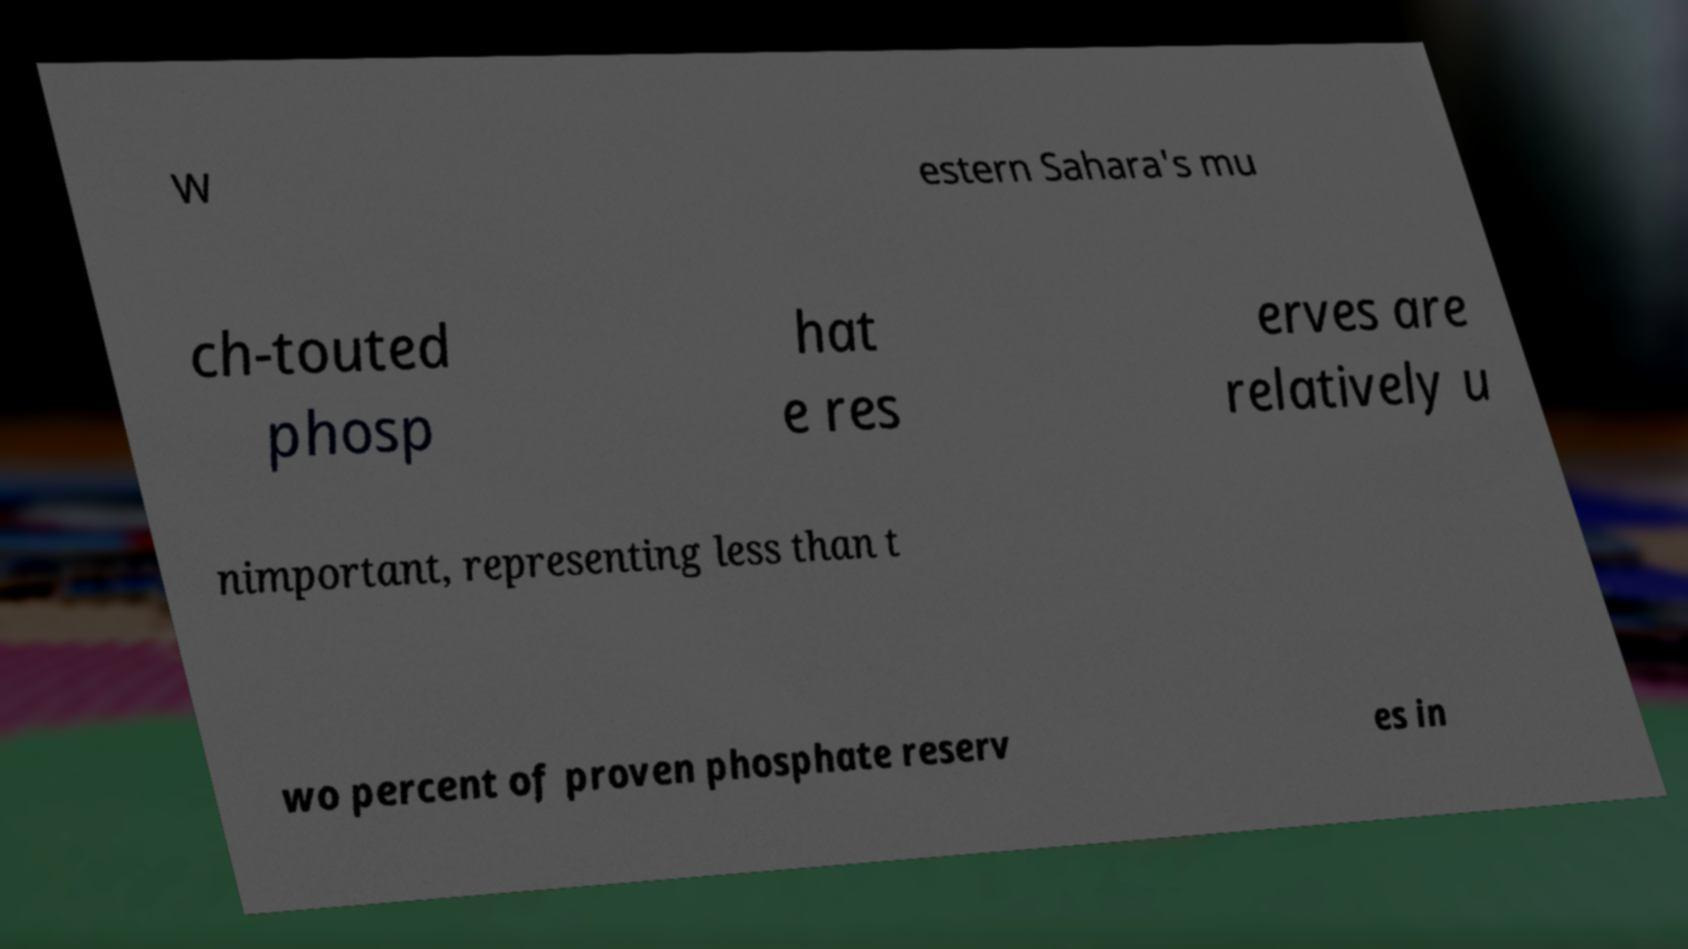Could you assist in decoding the text presented in this image and type it out clearly? W estern Sahara's mu ch-touted phosp hat e res erves are relatively u nimportant, representing less than t wo percent of proven phosphate reserv es in 